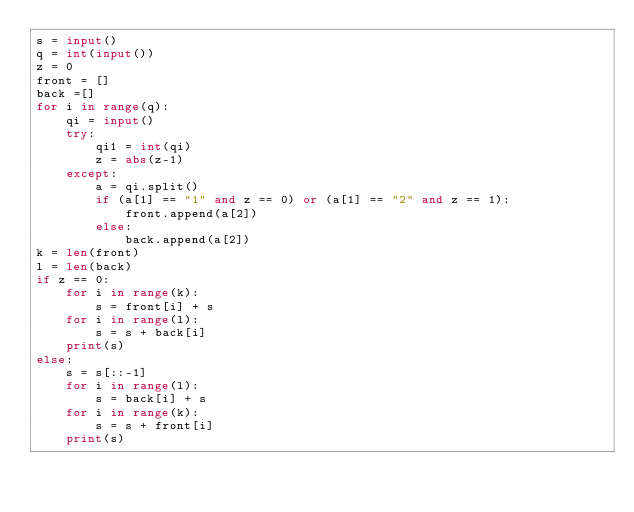<code> <loc_0><loc_0><loc_500><loc_500><_Python_>s = input()
q = int(input())
z = 0
front = []
back =[]
for i in range(q):
    qi = input()
    try:
        qi1 = int(qi)
        z = abs(z-1)
    except:
        a = qi.split()
        if (a[1] == "1" and z == 0) or (a[1] == "2" and z == 1):
            front.append(a[2])
        else:
            back.append(a[2])
k = len(front)
l = len(back)
if z == 0:
    for i in range(k):
        s = front[i] + s
    for i in range(l):
        s = s + back[i]
    print(s)
else:
    s = s[::-1]
    for i in range(l):
        s = back[i] + s
    for i in range(k):
        s = s + front[i]
    print(s)</code> 